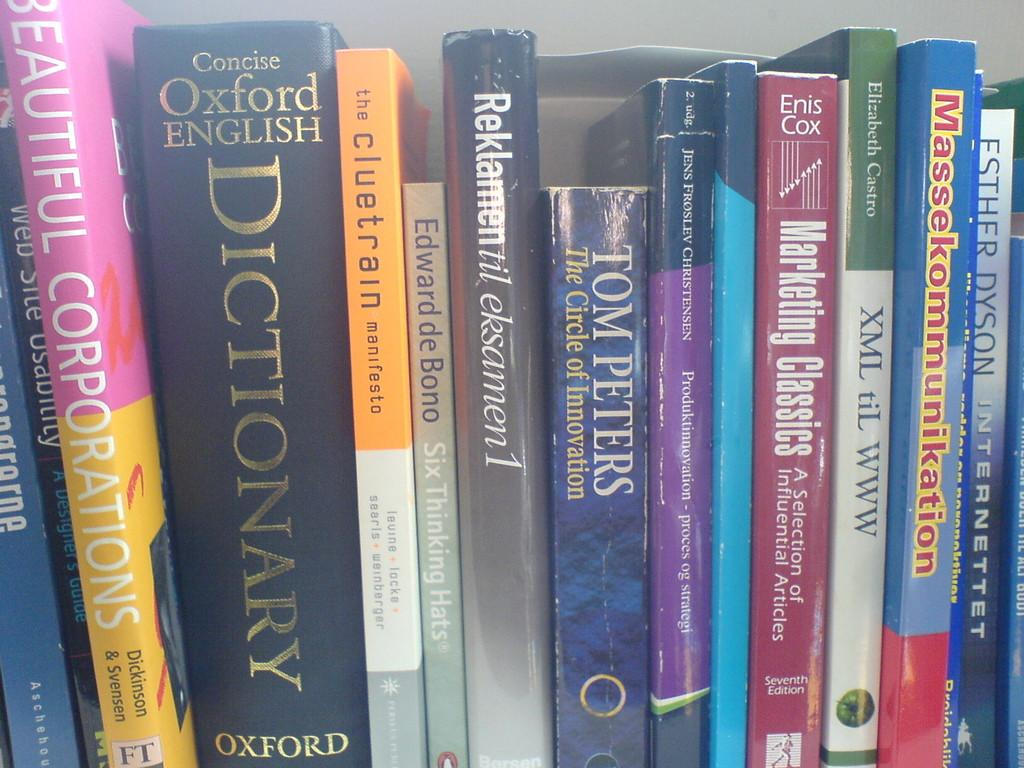<image>
Summarize the visual content of the image. a stack of books on a shelf like Tom Peters and Beautiful Corporations 